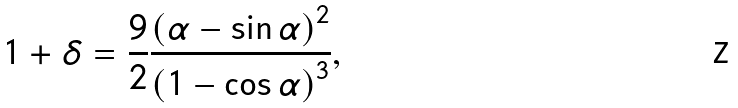Convert formula to latex. <formula><loc_0><loc_0><loc_500><loc_500>1 + \delta = \frac { 9 } { 2 } \frac { \left ( \alpha - \sin \alpha \right ) ^ { 2 } } { \left ( 1 - \cos \alpha \right ) ^ { 3 } } ,</formula> 